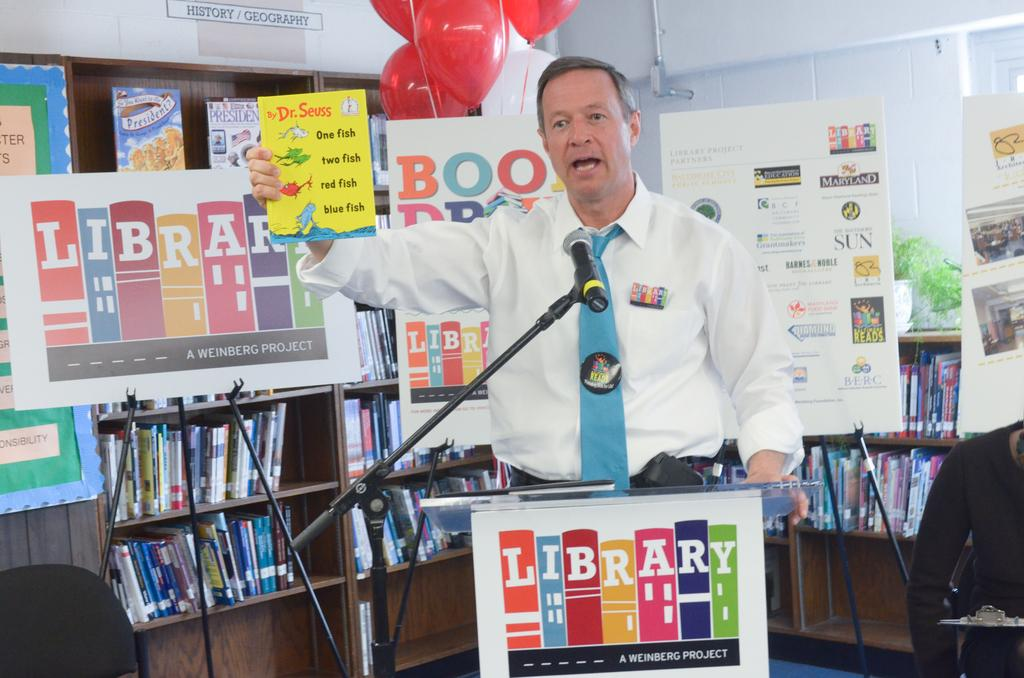<image>
Render a clear and concise summary of the photo. A man is giving a speech in front of a library sign. 